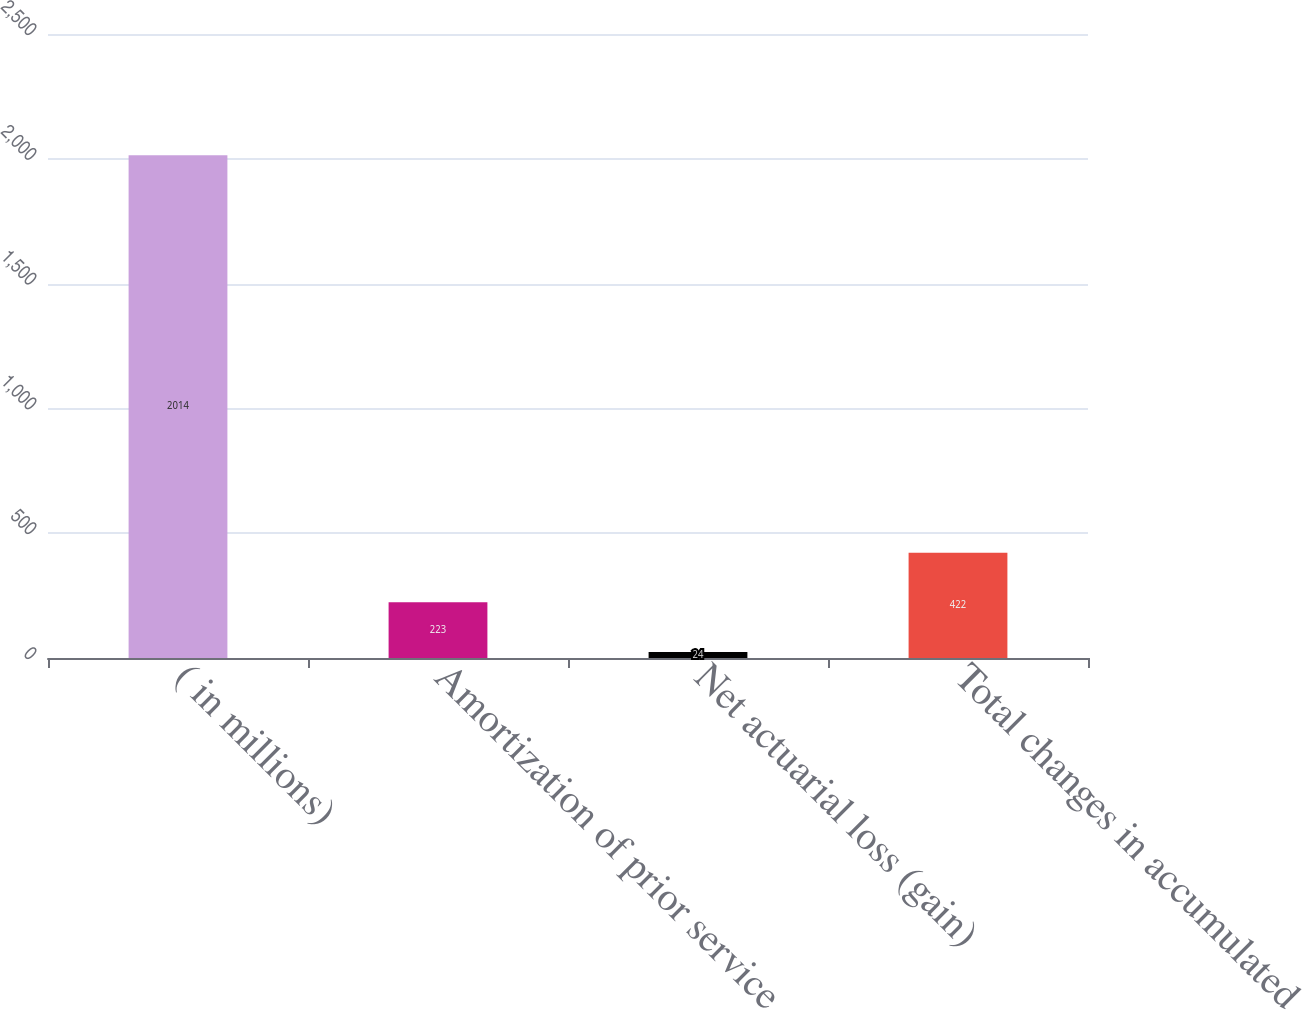<chart> <loc_0><loc_0><loc_500><loc_500><bar_chart><fcel>( in millions)<fcel>Amortization of prior service<fcel>Net actuarial loss (gain)<fcel>Total changes in accumulated<nl><fcel>2014<fcel>223<fcel>24<fcel>422<nl></chart> 